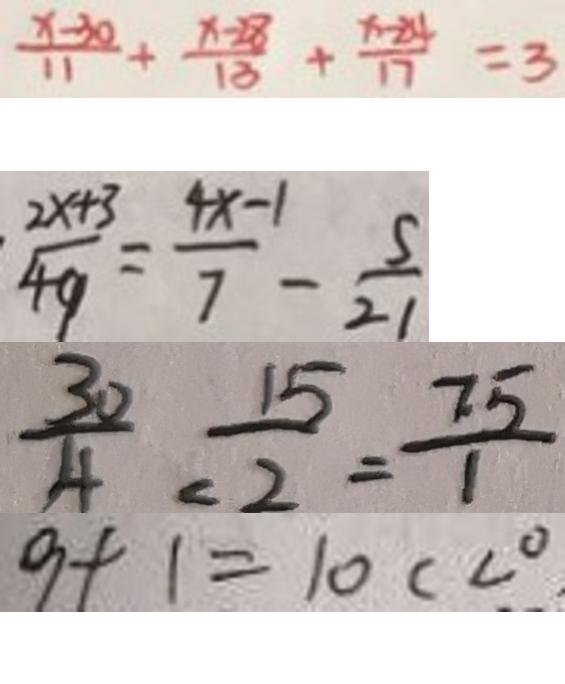<formula> <loc_0><loc_0><loc_500><loc_500>\frac { x - 3 0 } { 1 1 } + \frac { x - 2 8 } { 1 8 } + \frac { x - 2 4 } { 1 7 } = 3 
 \frac { 2 x + 3 } { 4 9 } = \frac { 4 x - 1 } { 7 } - \frac { 5 } { 2 1 } 
 \frac { 3 0 } { 4 } = \frac { 1 5 } { 2 } = \frac { 7 . 5 } { 1 } 
 9 + 1 = 1 0 c < 0</formula> 